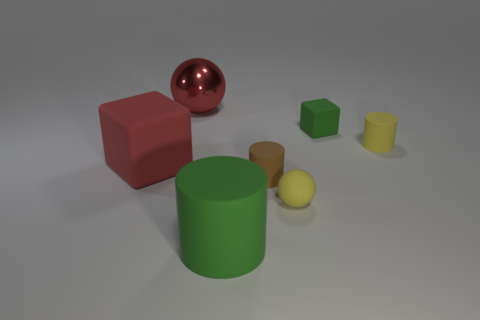Add 3 red spheres. How many objects exist? 10 Subtract all balls. How many objects are left? 5 Add 2 yellow cylinders. How many yellow cylinders are left? 3 Add 3 big blue blocks. How many big blue blocks exist? 3 Subtract 0 gray cylinders. How many objects are left? 7 Subtract all large things. Subtract all large red matte blocks. How many objects are left? 3 